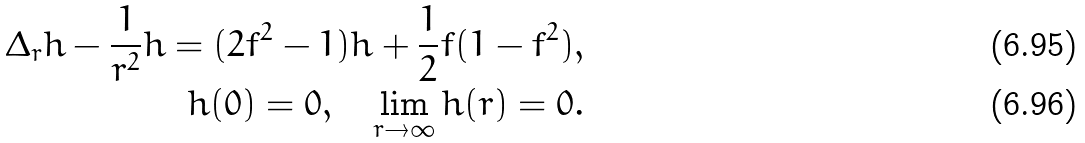Convert formula to latex. <formula><loc_0><loc_0><loc_500><loc_500>\Delta _ { r } h - \frac { 1 } { r ^ { 2 } } h = ( 2 f ^ { 2 } - 1 ) h + \frac { 1 } { 2 } f ( 1 - f ^ { 2 } ) , \\ h ( 0 ) = 0 , \quad \lim _ { r \to \infty } h ( r ) = 0 .</formula> 